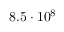Convert formula to latex. <formula><loc_0><loc_0><loc_500><loc_500>8 . 5 \cdot 1 0 ^ { 8 }</formula> 